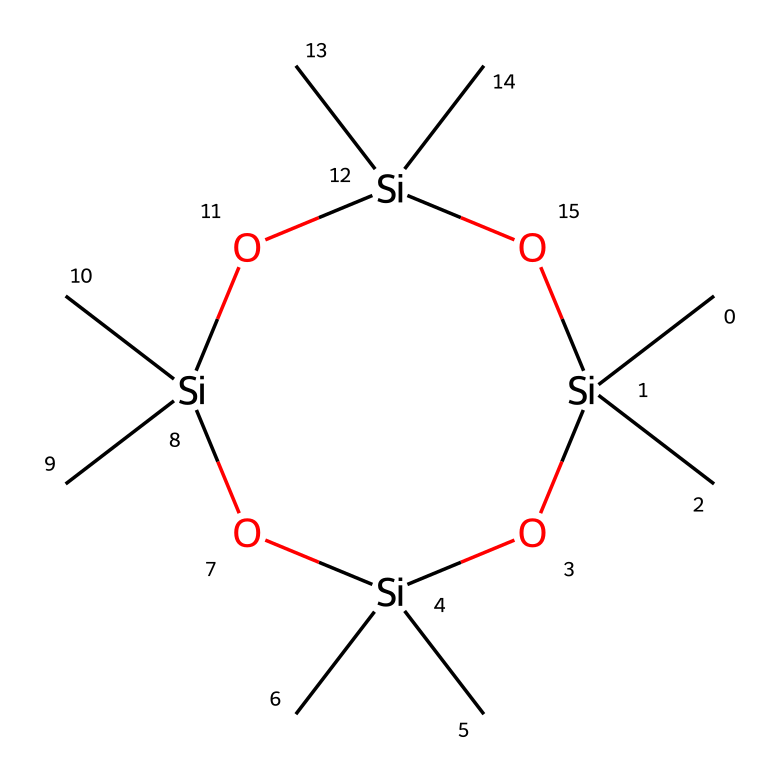What is the molecular formula of octamethylcyclotetrasiloxane? The SMILES representation indicates that the chemical consists of 4 silicon (Si) atoms and 12 carbon (C) atoms. By counting the total number of carbon and silicon atoms, we deduce the molecular formula is C12H36O4Si4.
Answer: C12H36O4Si4 How many oxygen atoms are present in the structure? The SMILES representation shows that there are four oxygen atoms (O) in the cyclic structure of octamethylcyclotetrasiloxane. By reviewing the components in the SMILES notation, we see the presence of four "O" notations.
Answer: 4 What type of chemical bonding is primarily present in siloxane compounds? Siloxane compounds like octamethylcyclotetrasiloxane predominantly feature Si-O (silicon-oxygen) bonds, which are crucial to their molecular structure and properties. By observing the arrangement in the SMILES, we can identify the Si-O linkages that dominate.
Answer: Si-O How many silicon atoms are present in octamethylcyclotetrasiloxane? The SMILES representation indicates that there are four silicon (Si) atoms involved in the structure. Counting the "Si" occurrences in the notation shows a total of four silicon atoms.
Answer: 4 Is octamethylcyclotetrasiloxane a cyclic or linear structure? The presence of the "1" in the SMILES notation indicates a cyclic structure, meaning the atoms are arranged in a loop or ring. This notation shows that the compound is indeed cyclic, specifically forming a closed-loop with alternating Si and O atoms.
Answer: cyclic How many methyl groups are attached to the silicon atoms? Each silicon atom in the structure is bonded to three methyl (−CH3) groups. Since there are four silicon atoms, we calculate 4 Si × 3 = 12 methyl groups attached.
Answer: 12 